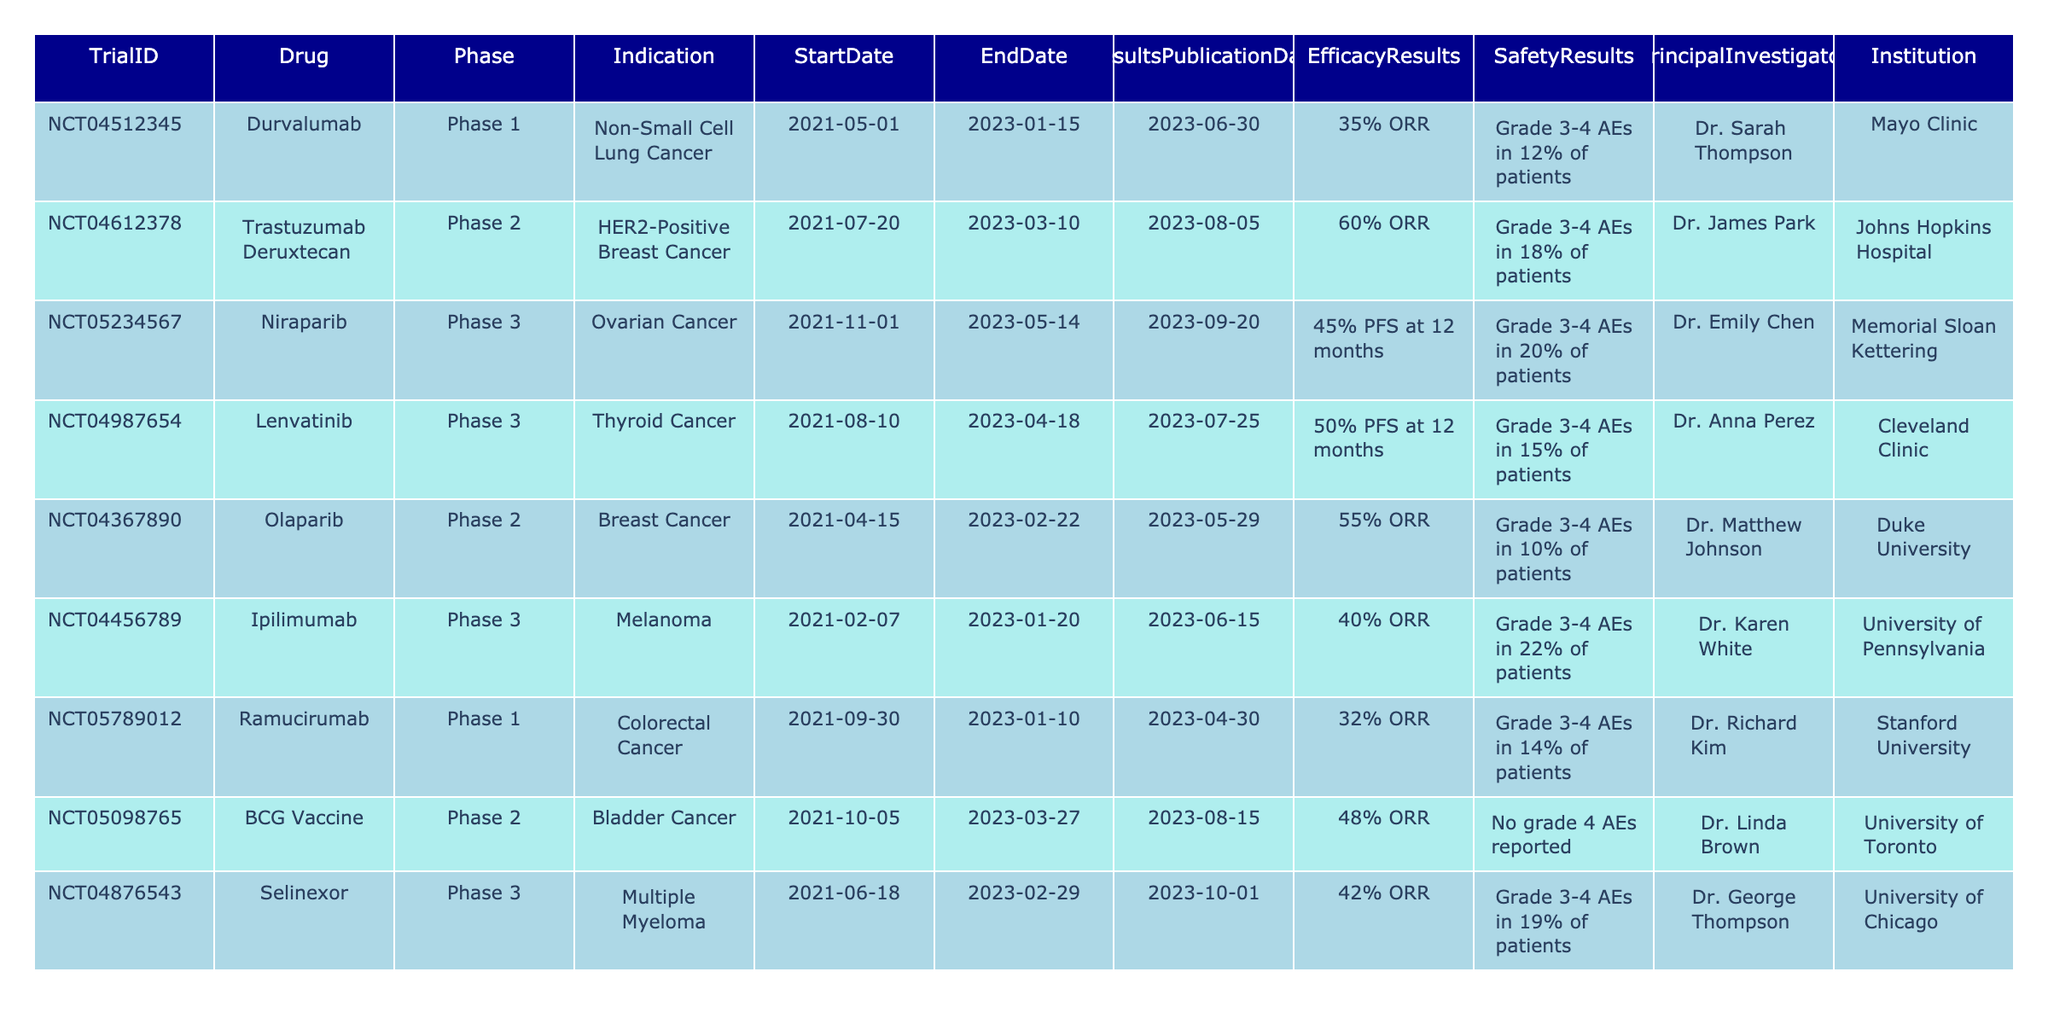What is the indication for the trial with the Drug 'Niraparib'? The table lists 'Niraparib' under the column for indications, which shows it is for 'Ovarian Cancer'.
Answer: Ovarian Cancer Which trial had the highest reported efficacy result? By comparing the efficacy results, 'Trastuzumab Deruxtecan' shows a '60% ORR', which is the highest among the trials listed.
Answer: Trastuzumab Deruxtecan Is there a trial that reported no grade 4 adverse events? Checking the safety results, the 'BCG Vaccine' trial is noted for reporting 'No grade 4 AEs', indicating such events did not occur in this trial.
Answer: Yes What is the average percentage of grade 3-4 adverse events reported across all trials? To calculate the average, sum the percentages of grade 3-4 AEs (12 + 18 + 20 + 15 + 10 + 22 + 14 + 0 + 19) = 120. There are 9 trials, so the average is 120/9 ≈ 13.33.
Answer: 13.33% Which drug is being investigated for Bladder Cancer? Referring to the table, the drug 'BCG Vaccine' is listed for the indication 'Bladder Cancer'.
Answer: BCG Vaccine What is the duration of the trial for 'Olaparib'? The trial dates for 'Olaparib' start on 2021-04-15 and end on 2023-02-22. The duration is from the start date to the end date, which is approximately 1 year and 10 months.
Answer: 1 year and 10 months Which two trials have the same phase and what are their indications? The trials for 'Lenvatinib' and 'Olaparib' both indicate they are in 'Phase 3', with indications 'Thyroid Cancer' and 'Breast Cancer', respectively.
Answer: Lenvatinib (Thyroid Cancer) and Olaparib (Breast Cancer) Out of the listed trials, which one was the last to publish results? Looking at the results publication dates, 'Selinexor' published its results on 2023-10-01, which is the latest date compared to others.
Answer: Selinexor How many drugs in the table are related to breast cancer? The drugs 'Trastuzumab Deruxtecan' and 'Olaparib' are related to breast cancer, indicating there are two such trials in the table.
Answer: 2 